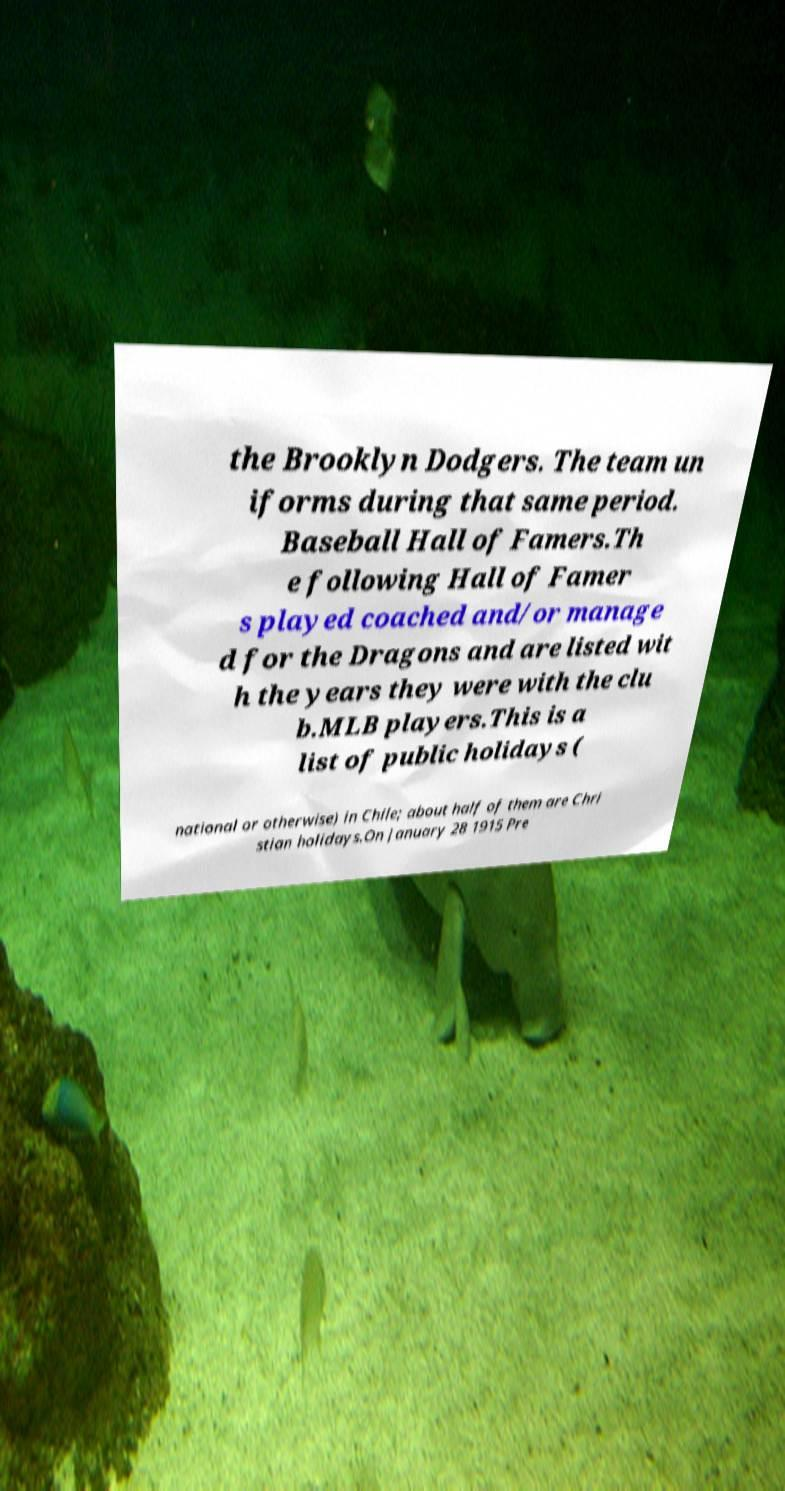Can you read and provide the text displayed in the image?This photo seems to have some interesting text. Can you extract and type it out for me? the Brooklyn Dodgers. The team un iforms during that same period. Baseball Hall of Famers.Th e following Hall of Famer s played coached and/or manage d for the Dragons and are listed wit h the years they were with the clu b.MLB players.This is a list of public holidays ( national or otherwise) in Chile; about half of them are Chri stian holidays.On January 28 1915 Pre 